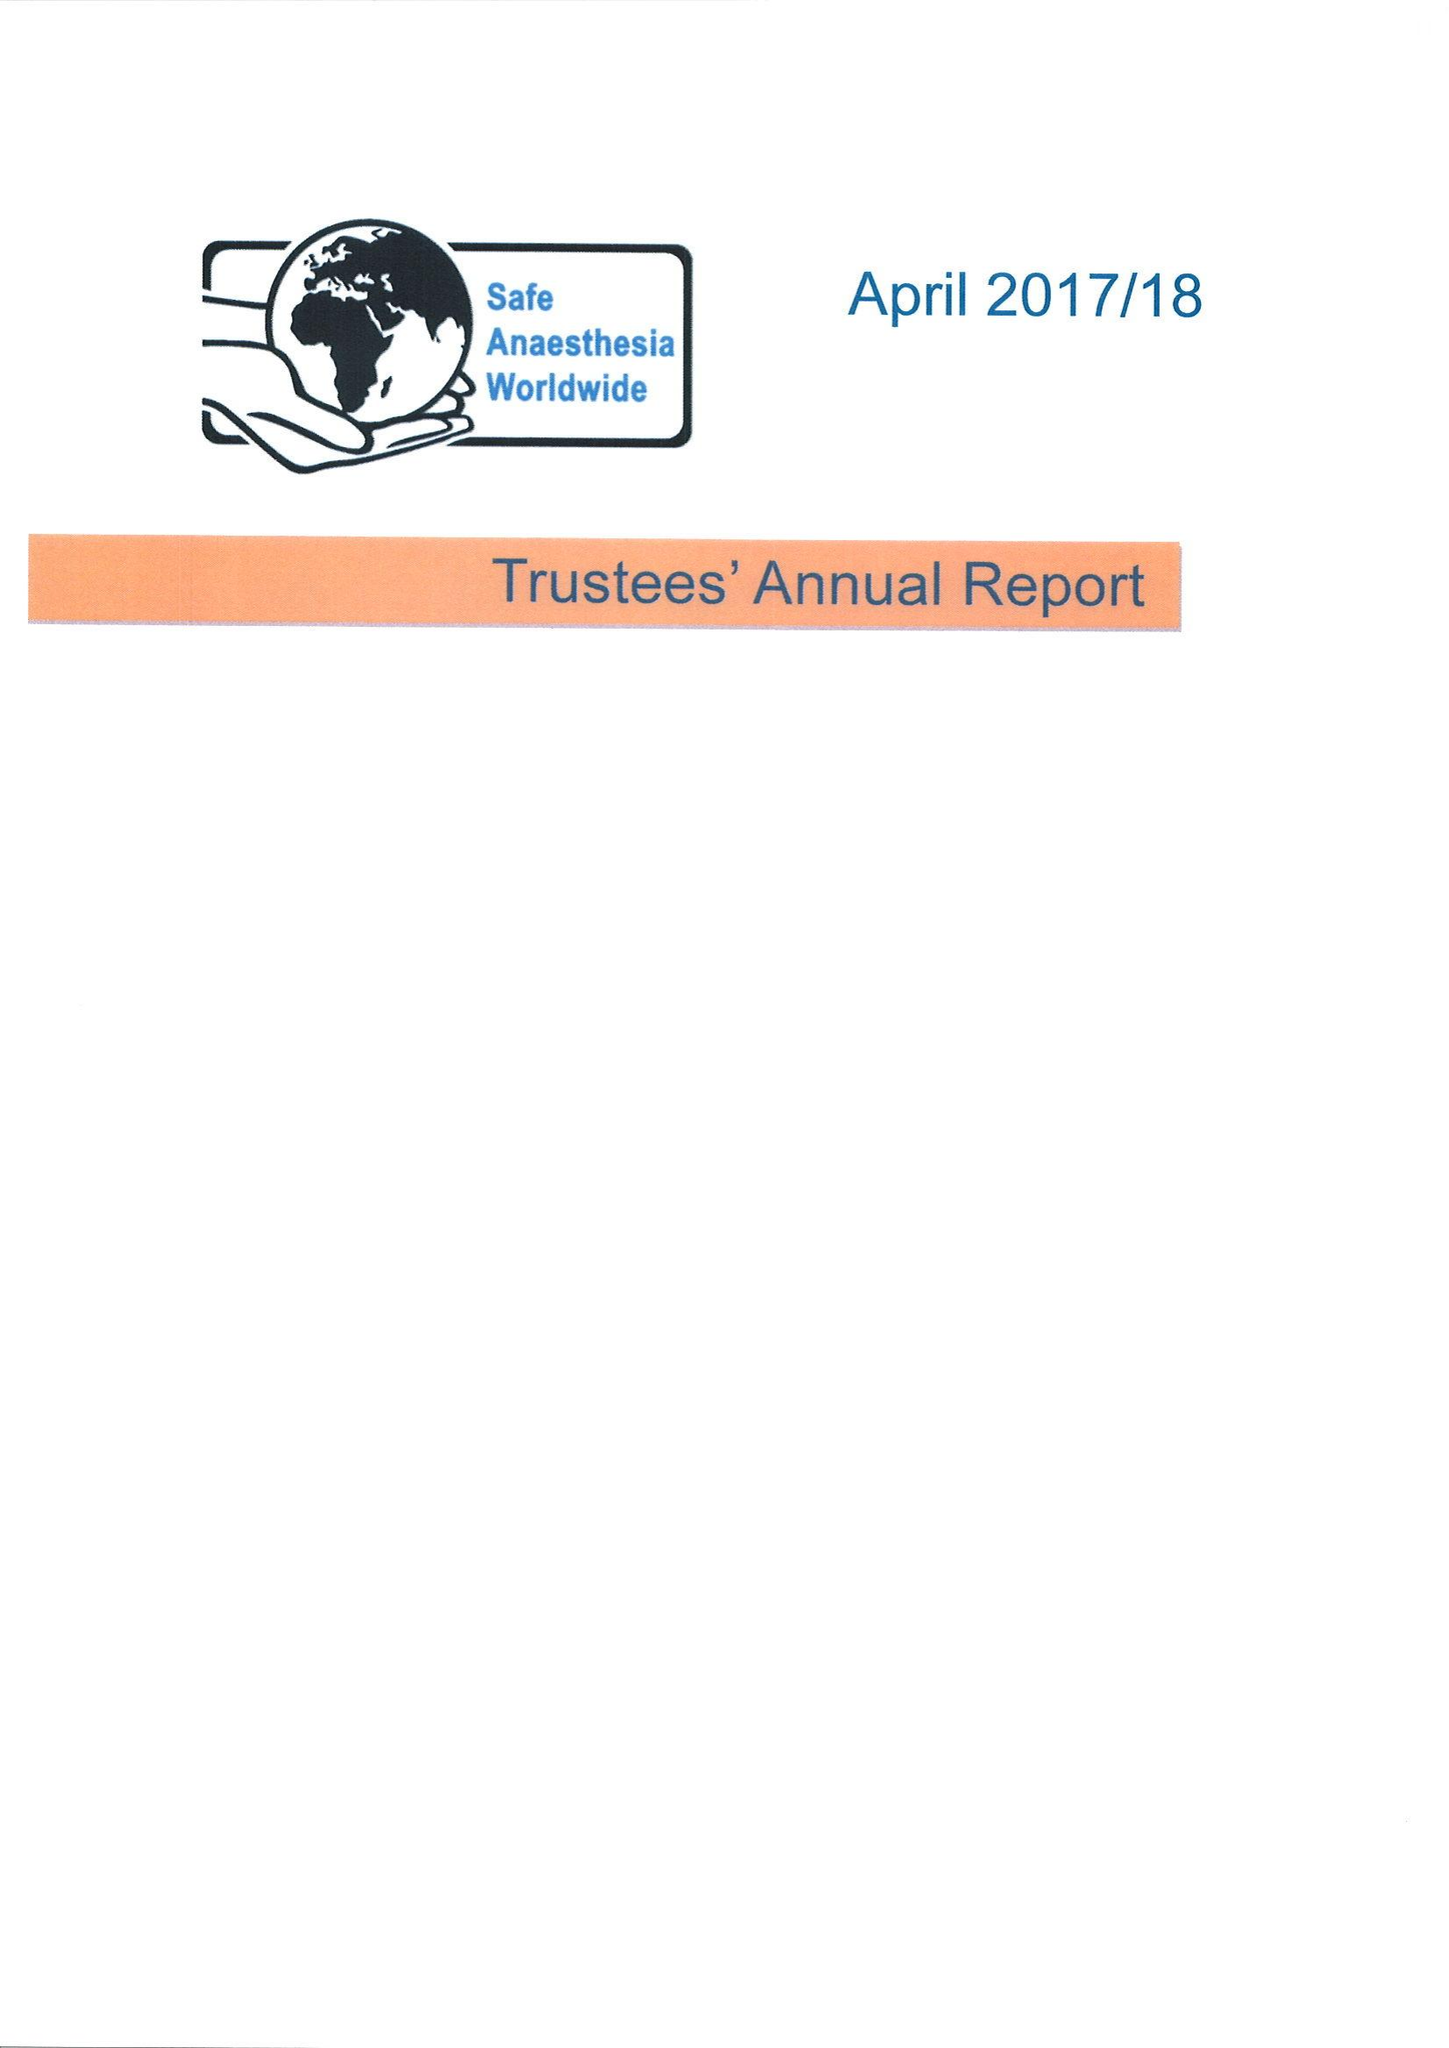What is the value for the address__street_line?
Answer the question using a single word or phrase. HIGH STREET 